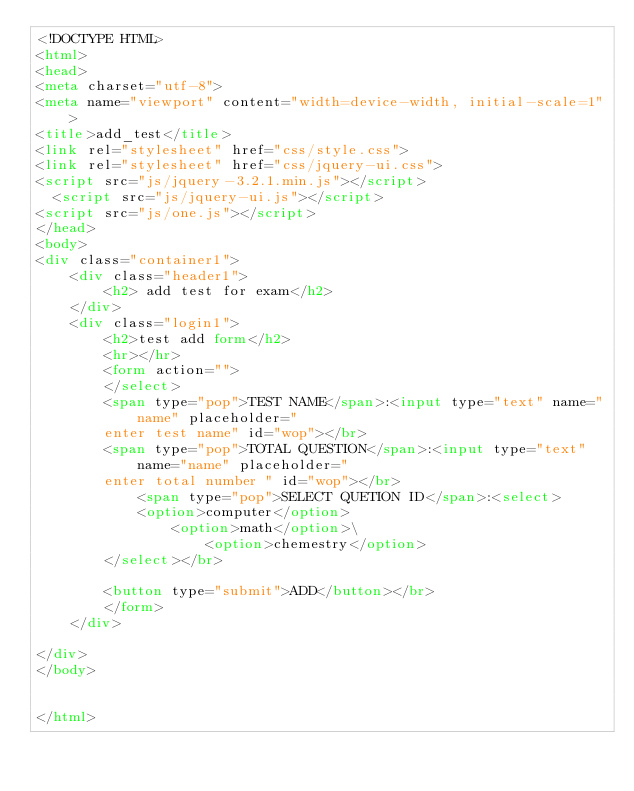Convert code to text. <code><loc_0><loc_0><loc_500><loc_500><_HTML_><!DOCTYPE HTML>
<html>
<head>
<meta charset="utf-8">
<meta name="viewport" content="width=device-width, initial-scale=1">
<title>add_test</title>
<link rel="stylesheet" href="css/style.css">
<link rel="stylesheet" href="css/jquery-ui.css">
<script src="js/jquery-3.2.1.min.js"></script>
  <script src="js/jquery-ui.js"></script>
<script src="js/one.js"></script>
</head>
<body>
<div class="container1">
	<div class="header1">
		<h2> add test for exam</h2>
	</div>
	<div class="login1">
		<h2>test add form</h2>
		<hr></hr>
		<form action="">
		</select>
		<span type="pop">TEST NAME</span>:<input type="text" name="name" placeholder=" 
		enter test name" id="wop"></br>
		<span type="pop">TOTAL QUESTION</span>:<input type="text" name="name" placeholder=" 
		enter total number " id="wop"></br>
			<span type="pop">SELECT QUETION ID</span>:<select>
			<option>computer</option>
				<option>math</option>\
					<option>chemestry</option>
		</select></br>
		
		<button type="submit">ADD</button></br>
		</form>
	</div>

</div>
</body>


</html></code> 